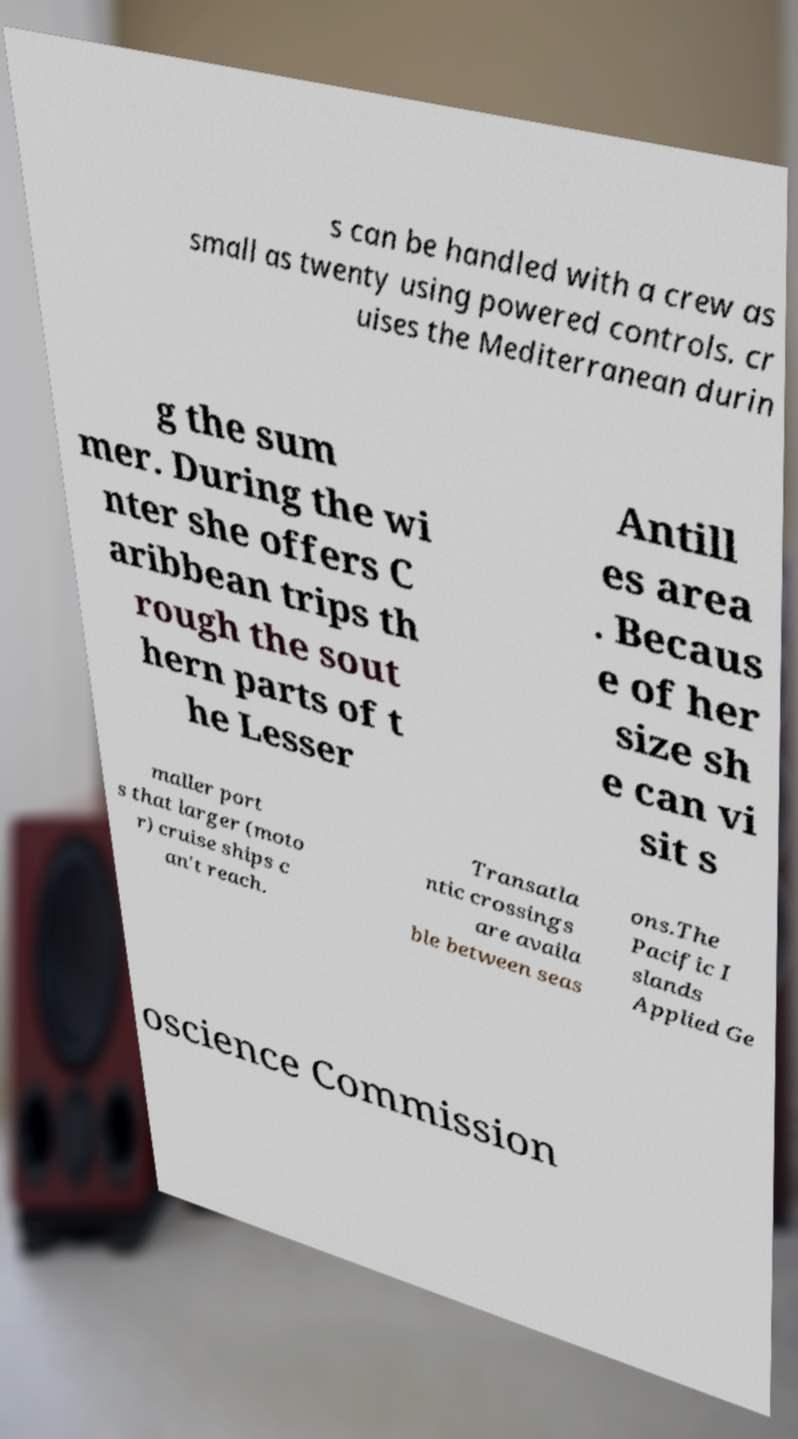Could you extract and type out the text from this image? s can be handled with a crew as small as twenty using powered controls. cr uises the Mediterranean durin g the sum mer. During the wi nter she offers C aribbean trips th rough the sout hern parts of t he Lesser Antill es area . Becaus e of her size sh e can vi sit s maller port s that larger (moto r) cruise ships c an't reach. Transatla ntic crossings are availa ble between seas ons.The Pacific I slands Applied Ge oscience Commission 